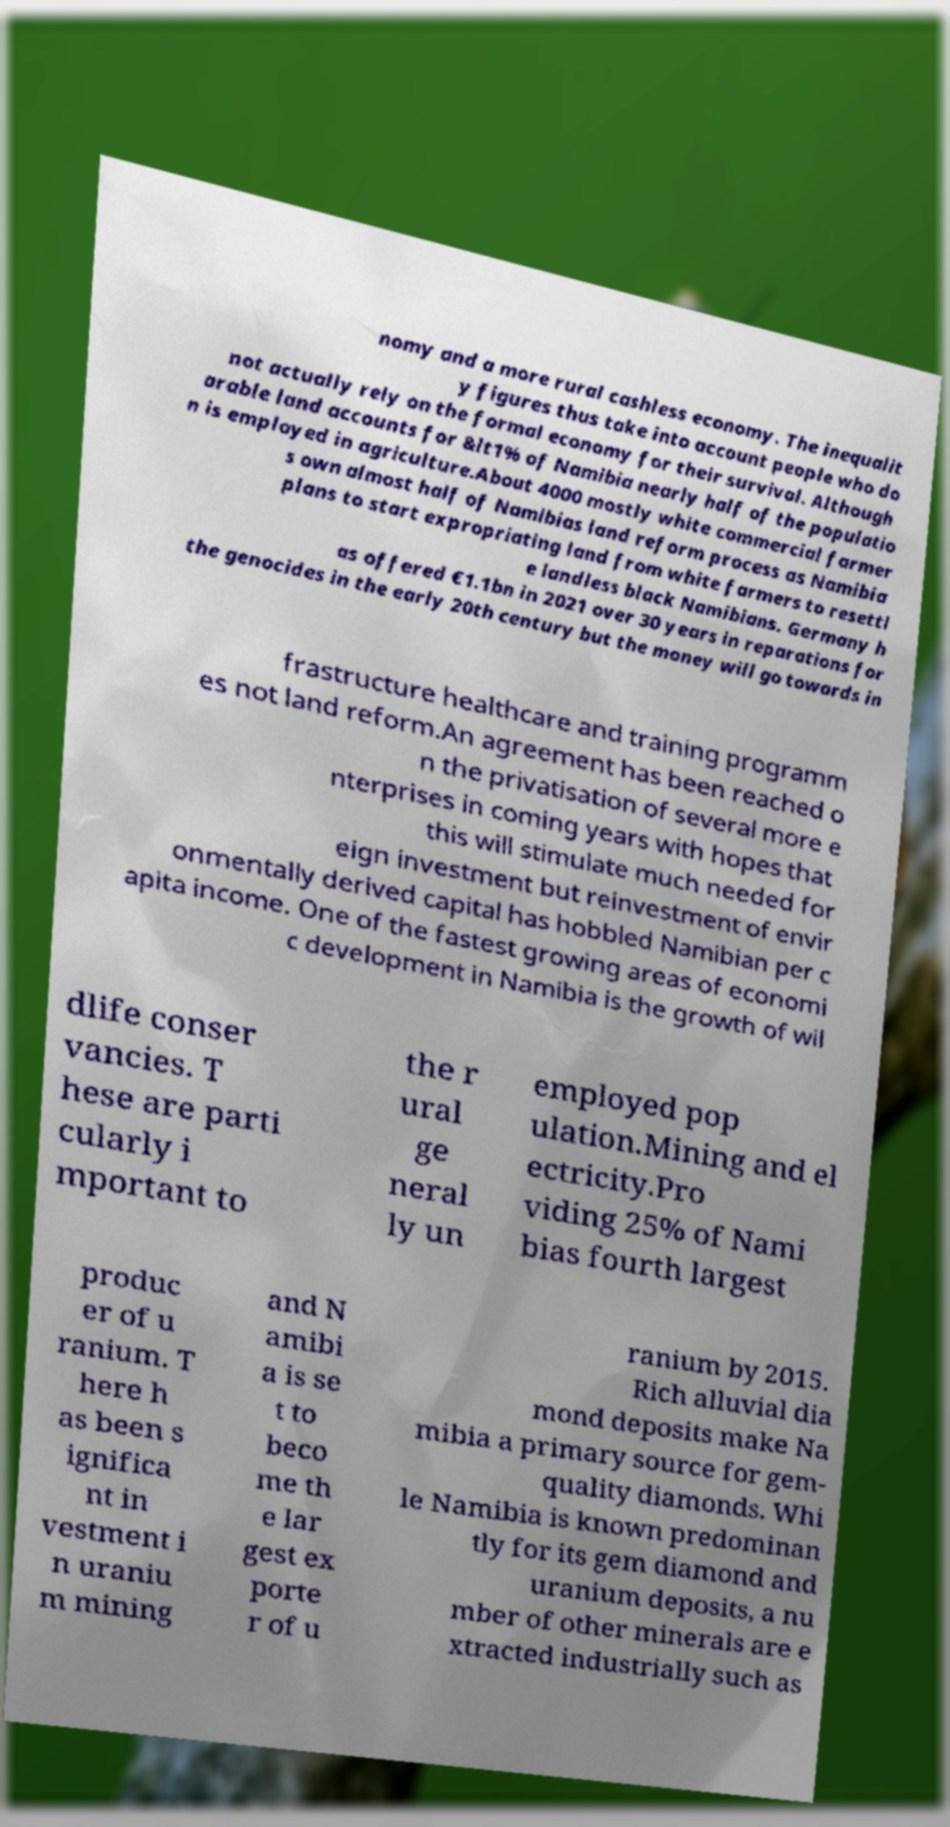There's text embedded in this image that I need extracted. Can you transcribe it verbatim? nomy and a more rural cashless economy. The inequalit y figures thus take into account people who do not actually rely on the formal economy for their survival. Although arable land accounts for &lt1% of Namibia nearly half of the populatio n is employed in agriculture.About 4000 mostly white commercial farmer s own almost half of Namibias land reform process as Namibia plans to start expropriating land from white farmers to resettl e landless black Namibians. Germany h as offered €1.1bn in 2021 over 30 years in reparations for the genocides in the early 20th century but the money will go towards in frastructure healthcare and training programm es not land reform.An agreement has been reached o n the privatisation of several more e nterprises in coming years with hopes that this will stimulate much needed for eign investment but reinvestment of envir onmentally derived capital has hobbled Namibian per c apita income. One of the fastest growing areas of economi c development in Namibia is the growth of wil dlife conser vancies. T hese are parti cularly i mportant to the r ural ge neral ly un employed pop ulation.Mining and el ectricity.Pro viding 25% of Nami bias fourth largest produc er of u ranium. T here h as been s ignifica nt in vestment i n uraniu m mining and N amibi a is se t to beco me th e lar gest ex porte r of u ranium by 2015. Rich alluvial dia mond deposits make Na mibia a primary source for gem- quality diamonds. Whi le Namibia is known predominan tly for its gem diamond and uranium deposits, a nu mber of other minerals are e xtracted industrially such as 